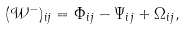<formula> <loc_0><loc_0><loc_500><loc_500>( \mathcal { W } ^ { - } ) _ { i j } = \Phi _ { i j } - \Psi _ { i j } + \Omega _ { i j } ,</formula> 